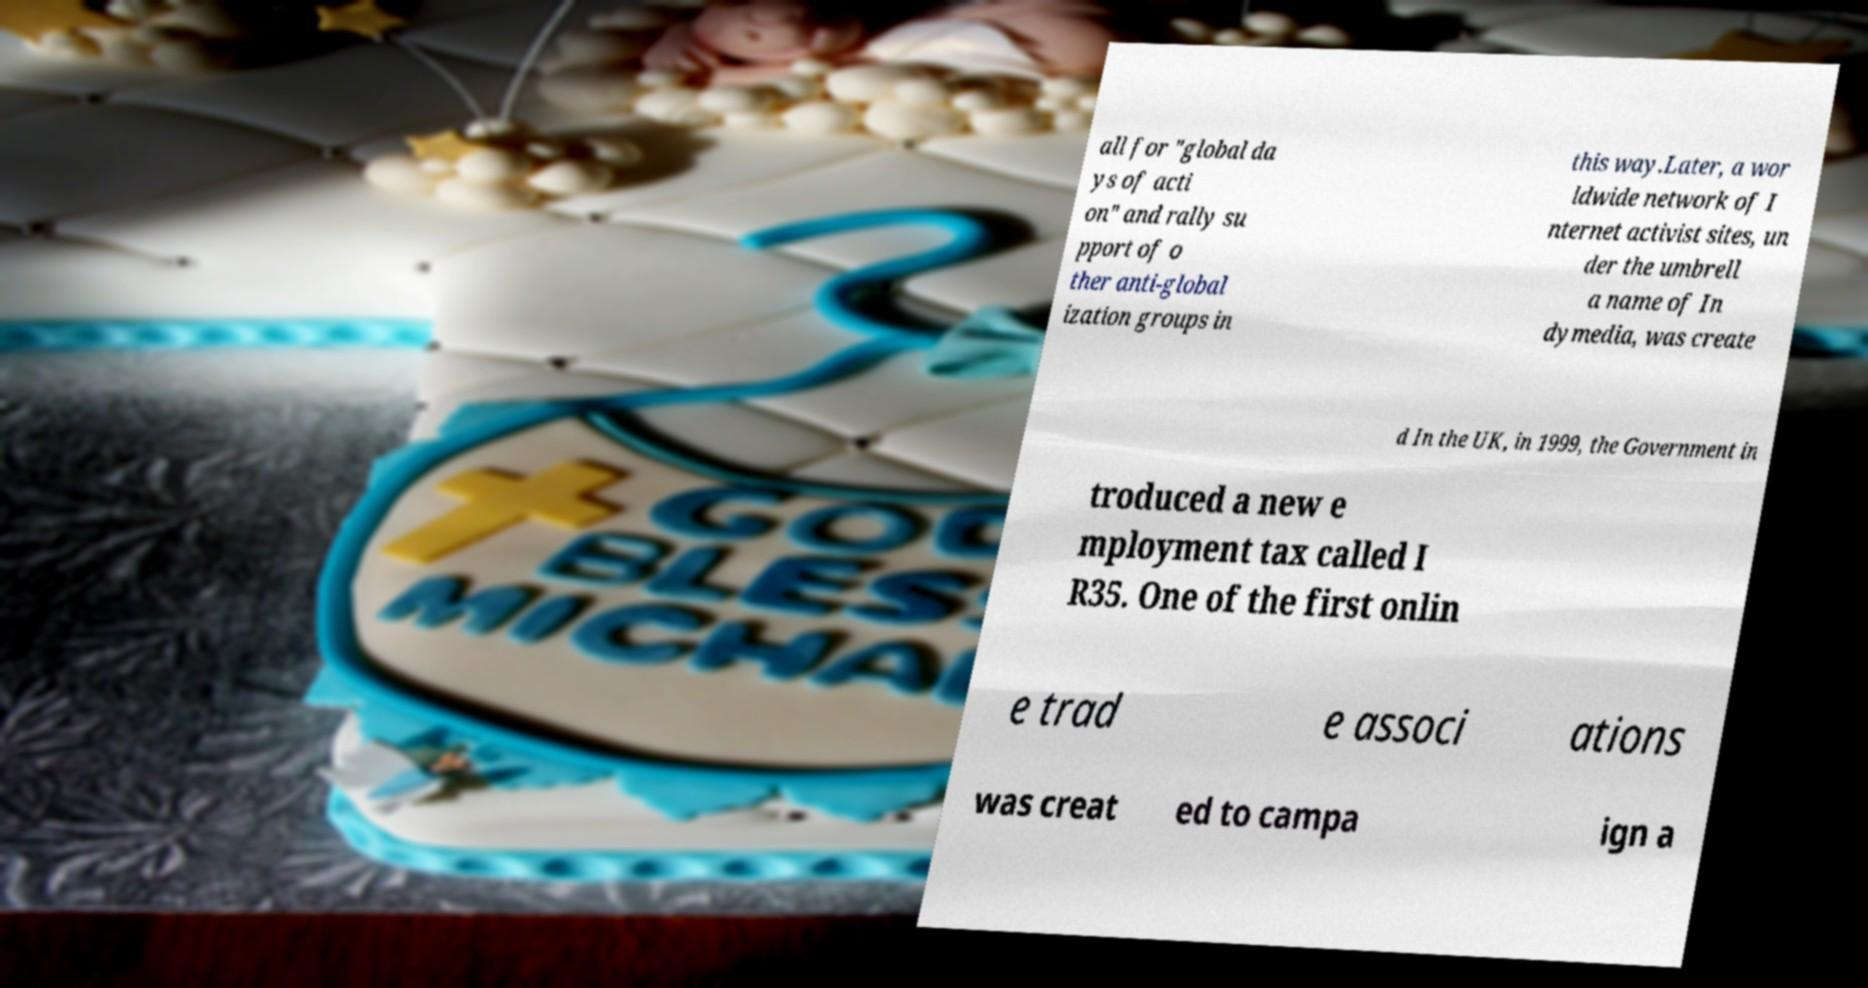For documentation purposes, I need the text within this image transcribed. Could you provide that? all for "global da ys of acti on" and rally su pport of o ther anti-global ization groups in this way.Later, a wor ldwide network of I nternet activist sites, un der the umbrell a name of In dymedia, was create d In the UK, in 1999, the Government in troduced a new e mployment tax called I R35. One of the first onlin e trad e associ ations was creat ed to campa ign a 